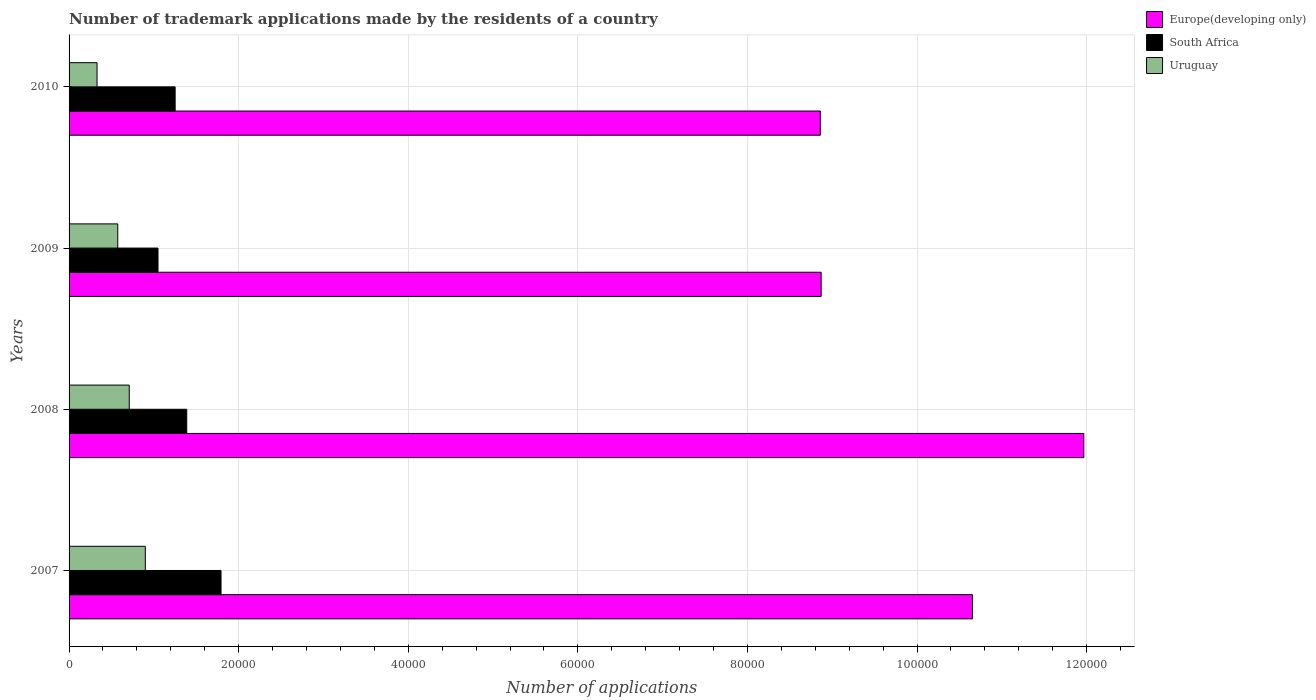How many groups of bars are there?
Keep it short and to the point. 4. What is the number of trademark applications made by the residents in South Africa in 2010?
Make the answer very short. 1.25e+04. Across all years, what is the maximum number of trademark applications made by the residents in Europe(developing only)?
Give a very brief answer. 1.20e+05. Across all years, what is the minimum number of trademark applications made by the residents in Uruguay?
Your response must be concise. 3300. In which year was the number of trademark applications made by the residents in Europe(developing only) maximum?
Ensure brevity in your answer.  2008. In which year was the number of trademark applications made by the residents in South Africa minimum?
Your answer should be very brief. 2009. What is the total number of trademark applications made by the residents in Europe(developing only) in the graph?
Give a very brief answer. 4.03e+05. What is the difference between the number of trademark applications made by the residents in South Africa in 2007 and that in 2008?
Keep it short and to the point. 4046. What is the difference between the number of trademark applications made by the residents in Europe(developing only) in 2009 and the number of trademark applications made by the residents in Uruguay in 2007?
Your response must be concise. 7.97e+04. What is the average number of trademark applications made by the residents in South Africa per year?
Provide a short and direct response. 1.37e+04. In the year 2007, what is the difference between the number of trademark applications made by the residents in Uruguay and number of trademark applications made by the residents in Europe(developing only)?
Offer a very short reply. -9.75e+04. What is the ratio of the number of trademark applications made by the residents in Uruguay in 2008 to that in 2009?
Make the answer very short. 1.24. Is the number of trademark applications made by the residents in South Africa in 2008 less than that in 2009?
Your answer should be compact. No. Is the difference between the number of trademark applications made by the residents in Uruguay in 2007 and 2009 greater than the difference between the number of trademark applications made by the residents in Europe(developing only) in 2007 and 2009?
Keep it short and to the point. No. What is the difference between the highest and the second highest number of trademark applications made by the residents in Europe(developing only)?
Give a very brief answer. 1.31e+04. What is the difference between the highest and the lowest number of trademark applications made by the residents in Uruguay?
Give a very brief answer. 5691. In how many years, is the number of trademark applications made by the residents in Uruguay greater than the average number of trademark applications made by the residents in Uruguay taken over all years?
Your answer should be very brief. 2. What does the 1st bar from the top in 2009 represents?
Provide a short and direct response. Uruguay. What does the 3rd bar from the bottom in 2008 represents?
Give a very brief answer. Uruguay. Are all the bars in the graph horizontal?
Provide a short and direct response. Yes. What is the difference between two consecutive major ticks on the X-axis?
Make the answer very short. 2.00e+04. Are the values on the major ticks of X-axis written in scientific E-notation?
Offer a terse response. No. Does the graph contain grids?
Give a very brief answer. Yes. What is the title of the graph?
Your answer should be compact. Number of trademark applications made by the residents of a country. What is the label or title of the X-axis?
Your response must be concise. Number of applications. What is the label or title of the Y-axis?
Provide a short and direct response. Years. What is the Number of applications in Europe(developing only) in 2007?
Ensure brevity in your answer.  1.07e+05. What is the Number of applications of South Africa in 2007?
Make the answer very short. 1.79e+04. What is the Number of applications of Uruguay in 2007?
Ensure brevity in your answer.  8991. What is the Number of applications in Europe(developing only) in 2008?
Make the answer very short. 1.20e+05. What is the Number of applications of South Africa in 2008?
Your answer should be very brief. 1.39e+04. What is the Number of applications of Uruguay in 2008?
Ensure brevity in your answer.  7096. What is the Number of applications in Europe(developing only) in 2009?
Keep it short and to the point. 8.87e+04. What is the Number of applications in South Africa in 2009?
Offer a very short reply. 1.05e+04. What is the Number of applications in Uruguay in 2009?
Your answer should be very brief. 5741. What is the Number of applications in Europe(developing only) in 2010?
Make the answer very short. 8.86e+04. What is the Number of applications of South Africa in 2010?
Give a very brief answer. 1.25e+04. What is the Number of applications of Uruguay in 2010?
Provide a succinct answer. 3300. Across all years, what is the maximum Number of applications in Europe(developing only)?
Your response must be concise. 1.20e+05. Across all years, what is the maximum Number of applications in South Africa?
Make the answer very short. 1.79e+04. Across all years, what is the maximum Number of applications of Uruguay?
Your answer should be compact. 8991. Across all years, what is the minimum Number of applications of Europe(developing only)?
Give a very brief answer. 8.86e+04. Across all years, what is the minimum Number of applications in South Africa?
Your answer should be compact. 1.05e+04. Across all years, what is the minimum Number of applications of Uruguay?
Provide a short and direct response. 3300. What is the total Number of applications in Europe(developing only) in the graph?
Your answer should be compact. 4.03e+05. What is the total Number of applications of South Africa in the graph?
Your answer should be very brief. 5.48e+04. What is the total Number of applications of Uruguay in the graph?
Ensure brevity in your answer.  2.51e+04. What is the difference between the Number of applications in Europe(developing only) in 2007 and that in 2008?
Keep it short and to the point. -1.31e+04. What is the difference between the Number of applications in South Africa in 2007 and that in 2008?
Offer a very short reply. 4046. What is the difference between the Number of applications of Uruguay in 2007 and that in 2008?
Provide a short and direct response. 1895. What is the difference between the Number of applications of Europe(developing only) in 2007 and that in 2009?
Make the answer very short. 1.78e+04. What is the difference between the Number of applications in South Africa in 2007 and that in 2009?
Your response must be concise. 7434. What is the difference between the Number of applications of Uruguay in 2007 and that in 2009?
Provide a succinct answer. 3250. What is the difference between the Number of applications of Europe(developing only) in 2007 and that in 2010?
Ensure brevity in your answer.  1.79e+04. What is the difference between the Number of applications of South Africa in 2007 and that in 2010?
Ensure brevity in your answer.  5412. What is the difference between the Number of applications of Uruguay in 2007 and that in 2010?
Give a very brief answer. 5691. What is the difference between the Number of applications in Europe(developing only) in 2008 and that in 2009?
Give a very brief answer. 3.10e+04. What is the difference between the Number of applications of South Africa in 2008 and that in 2009?
Make the answer very short. 3388. What is the difference between the Number of applications of Uruguay in 2008 and that in 2009?
Your response must be concise. 1355. What is the difference between the Number of applications of Europe(developing only) in 2008 and that in 2010?
Provide a short and direct response. 3.11e+04. What is the difference between the Number of applications of South Africa in 2008 and that in 2010?
Your answer should be very brief. 1366. What is the difference between the Number of applications in Uruguay in 2008 and that in 2010?
Provide a short and direct response. 3796. What is the difference between the Number of applications in South Africa in 2009 and that in 2010?
Keep it short and to the point. -2022. What is the difference between the Number of applications in Uruguay in 2009 and that in 2010?
Provide a succinct answer. 2441. What is the difference between the Number of applications of Europe(developing only) in 2007 and the Number of applications of South Africa in 2008?
Offer a very short reply. 9.27e+04. What is the difference between the Number of applications of Europe(developing only) in 2007 and the Number of applications of Uruguay in 2008?
Give a very brief answer. 9.94e+04. What is the difference between the Number of applications of South Africa in 2007 and the Number of applications of Uruguay in 2008?
Your response must be concise. 1.08e+04. What is the difference between the Number of applications in Europe(developing only) in 2007 and the Number of applications in South Africa in 2009?
Provide a short and direct response. 9.60e+04. What is the difference between the Number of applications in Europe(developing only) in 2007 and the Number of applications in Uruguay in 2009?
Keep it short and to the point. 1.01e+05. What is the difference between the Number of applications of South Africa in 2007 and the Number of applications of Uruguay in 2009?
Offer a terse response. 1.22e+04. What is the difference between the Number of applications of Europe(developing only) in 2007 and the Number of applications of South Africa in 2010?
Offer a very short reply. 9.40e+04. What is the difference between the Number of applications in Europe(developing only) in 2007 and the Number of applications in Uruguay in 2010?
Provide a succinct answer. 1.03e+05. What is the difference between the Number of applications in South Africa in 2007 and the Number of applications in Uruguay in 2010?
Ensure brevity in your answer.  1.46e+04. What is the difference between the Number of applications of Europe(developing only) in 2008 and the Number of applications of South Africa in 2009?
Keep it short and to the point. 1.09e+05. What is the difference between the Number of applications in Europe(developing only) in 2008 and the Number of applications in Uruguay in 2009?
Ensure brevity in your answer.  1.14e+05. What is the difference between the Number of applications of South Africa in 2008 and the Number of applications of Uruguay in 2009?
Offer a terse response. 8134. What is the difference between the Number of applications of Europe(developing only) in 2008 and the Number of applications of South Africa in 2010?
Your response must be concise. 1.07e+05. What is the difference between the Number of applications in Europe(developing only) in 2008 and the Number of applications in Uruguay in 2010?
Your answer should be very brief. 1.16e+05. What is the difference between the Number of applications in South Africa in 2008 and the Number of applications in Uruguay in 2010?
Your answer should be compact. 1.06e+04. What is the difference between the Number of applications of Europe(developing only) in 2009 and the Number of applications of South Africa in 2010?
Give a very brief answer. 7.62e+04. What is the difference between the Number of applications of Europe(developing only) in 2009 and the Number of applications of Uruguay in 2010?
Your response must be concise. 8.54e+04. What is the difference between the Number of applications of South Africa in 2009 and the Number of applications of Uruguay in 2010?
Ensure brevity in your answer.  7187. What is the average Number of applications of Europe(developing only) per year?
Give a very brief answer. 1.01e+05. What is the average Number of applications of South Africa per year?
Give a very brief answer. 1.37e+04. What is the average Number of applications of Uruguay per year?
Provide a short and direct response. 6282. In the year 2007, what is the difference between the Number of applications of Europe(developing only) and Number of applications of South Africa?
Keep it short and to the point. 8.86e+04. In the year 2007, what is the difference between the Number of applications in Europe(developing only) and Number of applications in Uruguay?
Ensure brevity in your answer.  9.75e+04. In the year 2007, what is the difference between the Number of applications in South Africa and Number of applications in Uruguay?
Your answer should be very brief. 8930. In the year 2008, what is the difference between the Number of applications in Europe(developing only) and Number of applications in South Africa?
Give a very brief answer. 1.06e+05. In the year 2008, what is the difference between the Number of applications in Europe(developing only) and Number of applications in Uruguay?
Give a very brief answer. 1.13e+05. In the year 2008, what is the difference between the Number of applications of South Africa and Number of applications of Uruguay?
Keep it short and to the point. 6779. In the year 2009, what is the difference between the Number of applications in Europe(developing only) and Number of applications in South Africa?
Your answer should be very brief. 7.82e+04. In the year 2009, what is the difference between the Number of applications in Europe(developing only) and Number of applications in Uruguay?
Your response must be concise. 8.30e+04. In the year 2009, what is the difference between the Number of applications in South Africa and Number of applications in Uruguay?
Your response must be concise. 4746. In the year 2010, what is the difference between the Number of applications of Europe(developing only) and Number of applications of South Africa?
Make the answer very short. 7.61e+04. In the year 2010, what is the difference between the Number of applications in Europe(developing only) and Number of applications in Uruguay?
Offer a terse response. 8.53e+04. In the year 2010, what is the difference between the Number of applications of South Africa and Number of applications of Uruguay?
Your answer should be very brief. 9209. What is the ratio of the Number of applications in Europe(developing only) in 2007 to that in 2008?
Offer a terse response. 0.89. What is the ratio of the Number of applications of South Africa in 2007 to that in 2008?
Your response must be concise. 1.29. What is the ratio of the Number of applications in Uruguay in 2007 to that in 2008?
Provide a succinct answer. 1.27. What is the ratio of the Number of applications in Europe(developing only) in 2007 to that in 2009?
Offer a very short reply. 1.2. What is the ratio of the Number of applications in South Africa in 2007 to that in 2009?
Ensure brevity in your answer.  1.71. What is the ratio of the Number of applications in Uruguay in 2007 to that in 2009?
Your response must be concise. 1.57. What is the ratio of the Number of applications of Europe(developing only) in 2007 to that in 2010?
Give a very brief answer. 1.2. What is the ratio of the Number of applications in South Africa in 2007 to that in 2010?
Make the answer very short. 1.43. What is the ratio of the Number of applications in Uruguay in 2007 to that in 2010?
Your response must be concise. 2.72. What is the ratio of the Number of applications of Europe(developing only) in 2008 to that in 2009?
Offer a very short reply. 1.35. What is the ratio of the Number of applications of South Africa in 2008 to that in 2009?
Give a very brief answer. 1.32. What is the ratio of the Number of applications in Uruguay in 2008 to that in 2009?
Your answer should be compact. 1.24. What is the ratio of the Number of applications in Europe(developing only) in 2008 to that in 2010?
Give a very brief answer. 1.35. What is the ratio of the Number of applications of South Africa in 2008 to that in 2010?
Offer a very short reply. 1.11. What is the ratio of the Number of applications in Uruguay in 2008 to that in 2010?
Offer a very short reply. 2.15. What is the ratio of the Number of applications in Europe(developing only) in 2009 to that in 2010?
Your answer should be very brief. 1. What is the ratio of the Number of applications of South Africa in 2009 to that in 2010?
Your response must be concise. 0.84. What is the ratio of the Number of applications of Uruguay in 2009 to that in 2010?
Give a very brief answer. 1.74. What is the difference between the highest and the second highest Number of applications in Europe(developing only)?
Your answer should be compact. 1.31e+04. What is the difference between the highest and the second highest Number of applications in South Africa?
Keep it short and to the point. 4046. What is the difference between the highest and the second highest Number of applications of Uruguay?
Make the answer very short. 1895. What is the difference between the highest and the lowest Number of applications in Europe(developing only)?
Offer a very short reply. 3.11e+04. What is the difference between the highest and the lowest Number of applications in South Africa?
Offer a terse response. 7434. What is the difference between the highest and the lowest Number of applications in Uruguay?
Provide a short and direct response. 5691. 